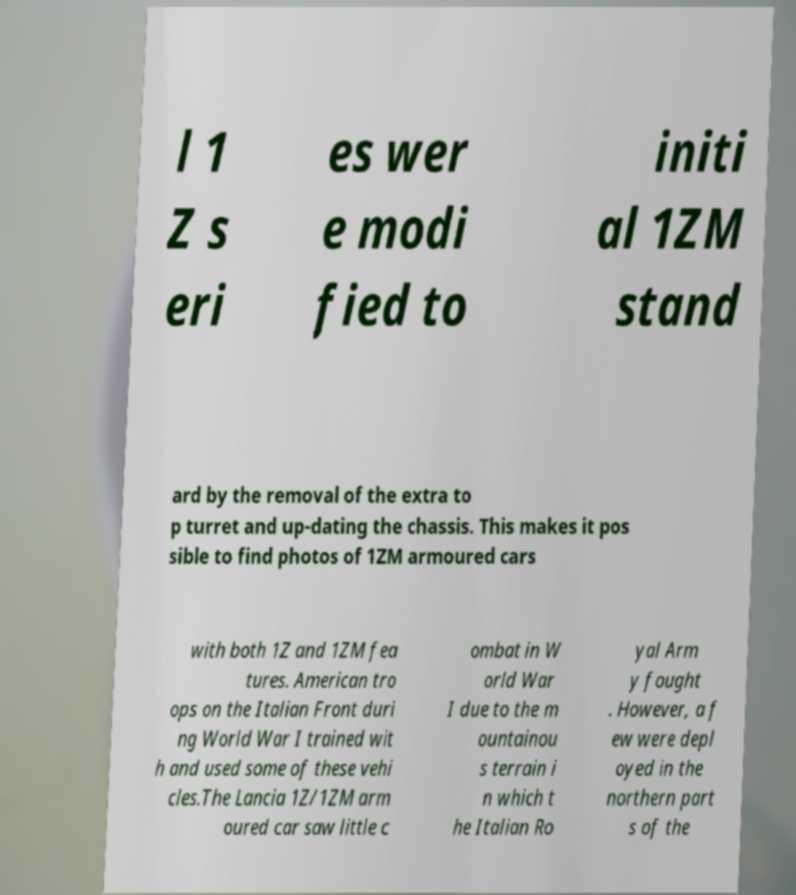Can you accurately transcribe the text from the provided image for me? l 1 Z s eri es wer e modi fied to initi al 1ZM stand ard by the removal of the extra to p turret and up-dating the chassis. This makes it pos sible to find photos of 1ZM armoured cars with both 1Z and 1ZM fea tures. American tro ops on the Italian Front duri ng World War I trained wit h and used some of these vehi cles.The Lancia 1Z/1ZM arm oured car saw little c ombat in W orld War I due to the m ountainou s terrain i n which t he Italian Ro yal Arm y fought . However, a f ew were depl oyed in the northern part s of the 